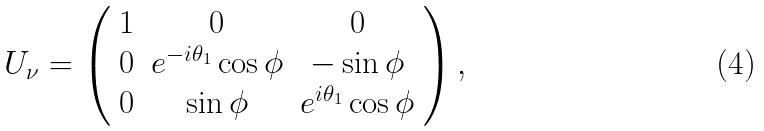<formula> <loc_0><loc_0><loc_500><loc_500>U _ { \nu } = \left ( \begin{array} { c c c } 1 & 0 & 0 \\ 0 & e ^ { - i \theta _ { 1 } } \cos \phi & - \sin \phi \\ 0 & \sin \phi & e ^ { i \theta _ { 1 } } \cos \phi \end{array} \right ) ,</formula> 